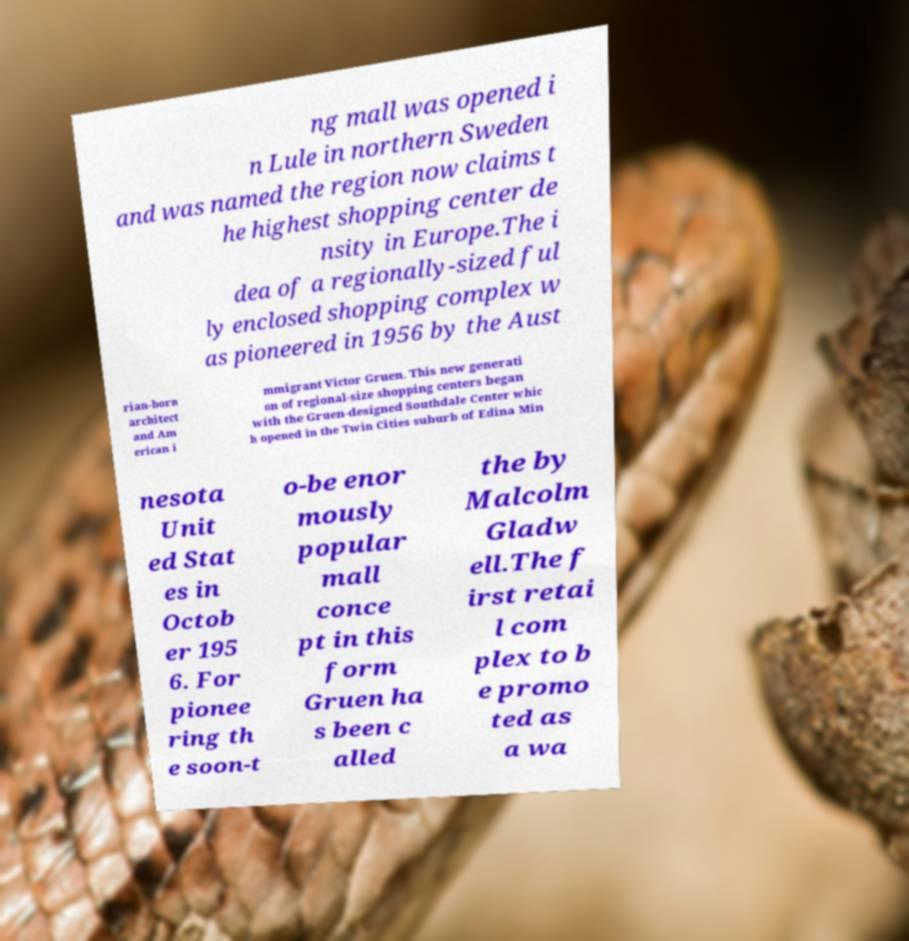Please identify and transcribe the text found in this image. ng mall was opened i n Lule in northern Sweden and was named the region now claims t he highest shopping center de nsity in Europe.The i dea of a regionally-sized ful ly enclosed shopping complex w as pioneered in 1956 by the Aust rian-born architect and Am erican i mmigrant Victor Gruen. This new generati on of regional-size shopping centers began with the Gruen-designed Southdale Center whic h opened in the Twin Cities suburb of Edina Min nesota Unit ed Stat es in Octob er 195 6. For pionee ring th e soon-t o-be enor mously popular mall conce pt in this form Gruen ha s been c alled the by Malcolm Gladw ell.The f irst retai l com plex to b e promo ted as a wa 